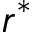Convert formula to latex. <formula><loc_0><loc_0><loc_500><loc_500>r ^ { * }</formula> 